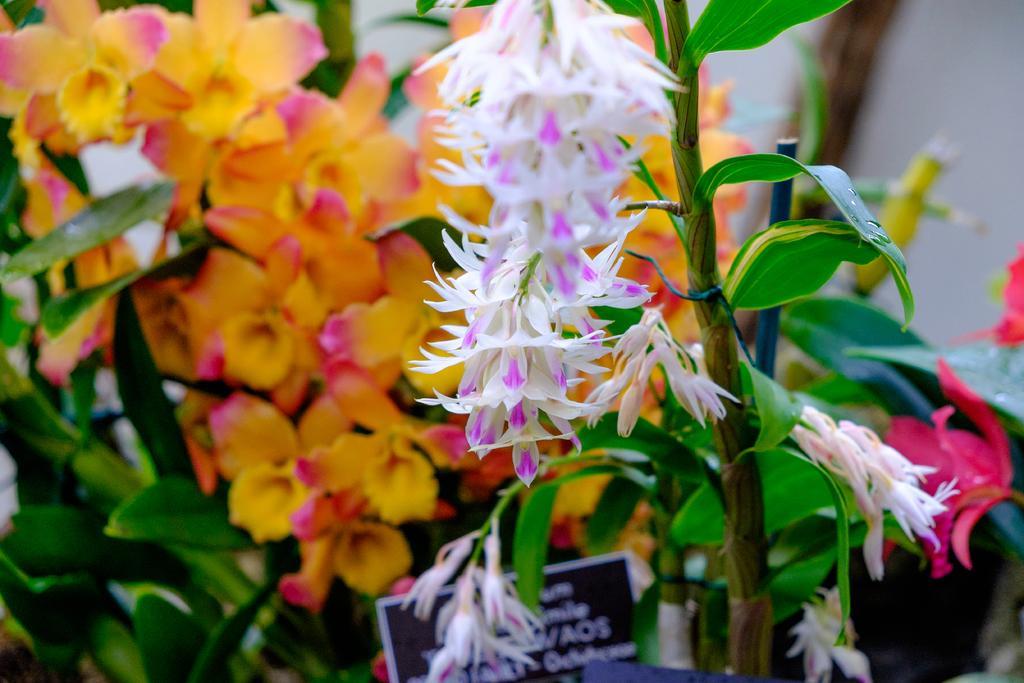In one or two sentences, can you explain what this image depicts? In this image I can see few flowers in white, purple, orange and pink color and I can see few leaves in green color. In front I can see the board in black and white color. 